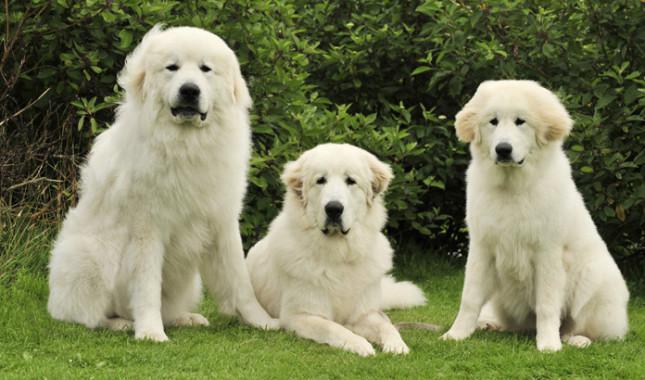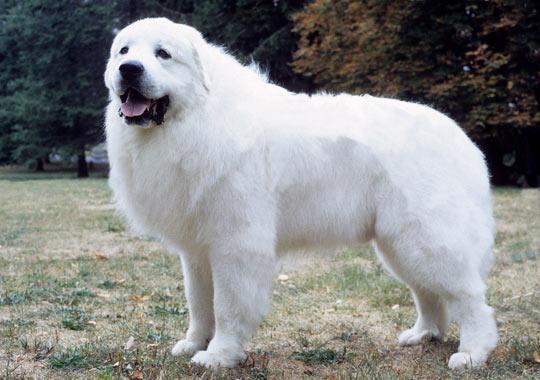The first image is the image on the left, the second image is the image on the right. Considering the images on both sides, is "There is a dog laying in the grass next to another dog" valid? Answer yes or no. Yes. The first image is the image on the left, the second image is the image on the right. For the images shown, is this caption "There are two dogs" true? Answer yes or no. No. The first image is the image on the left, the second image is the image on the right. Considering the images on both sides, is "At least one dog in an image in the pair has its mouth open and tongue visible." valid? Answer yes or no. Yes. The first image is the image on the left, the second image is the image on the right. Examine the images to the left and right. Is the description "There are no more than two white dogs." accurate? Answer yes or no. No. 